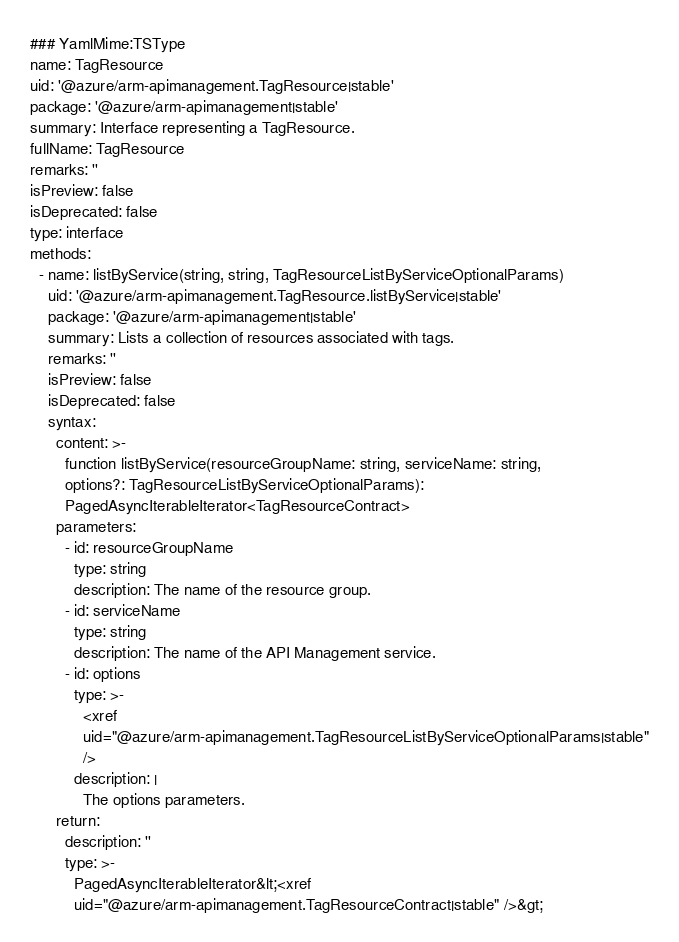Convert code to text. <code><loc_0><loc_0><loc_500><loc_500><_YAML_>### YamlMime:TSType
name: TagResource
uid: '@azure/arm-apimanagement.TagResource|stable'
package: '@azure/arm-apimanagement|stable'
summary: Interface representing a TagResource.
fullName: TagResource
remarks: ''
isPreview: false
isDeprecated: false
type: interface
methods:
  - name: listByService(string, string, TagResourceListByServiceOptionalParams)
    uid: '@azure/arm-apimanagement.TagResource.listByService|stable'
    package: '@azure/arm-apimanagement|stable'
    summary: Lists a collection of resources associated with tags.
    remarks: ''
    isPreview: false
    isDeprecated: false
    syntax:
      content: >-
        function listByService(resourceGroupName: string, serviceName: string,
        options?: TagResourceListByServiceOptionalParams):
        PagedAsyncIterableIterator<TagResourceContract>
      parameters:
        - id: resourceGroupName
          type: string
          description: The name of the resource group.
        - id: serviceName
          type: string
          description: The name of the API Management service.
        - id: options
          type: >-
            <xref
            uid="@azure/arm-apimanagement.TagResourceListByServiceOptionalParams|stable"
            />
          description: |
            The options parameters.
      return:
        description: ''
        type: >-
          PagedAsyncIterableIterator&lt;<xref
          uid="@azure/arm-apimanagement.TagResourceContract|stable" />&gt;
</code> 